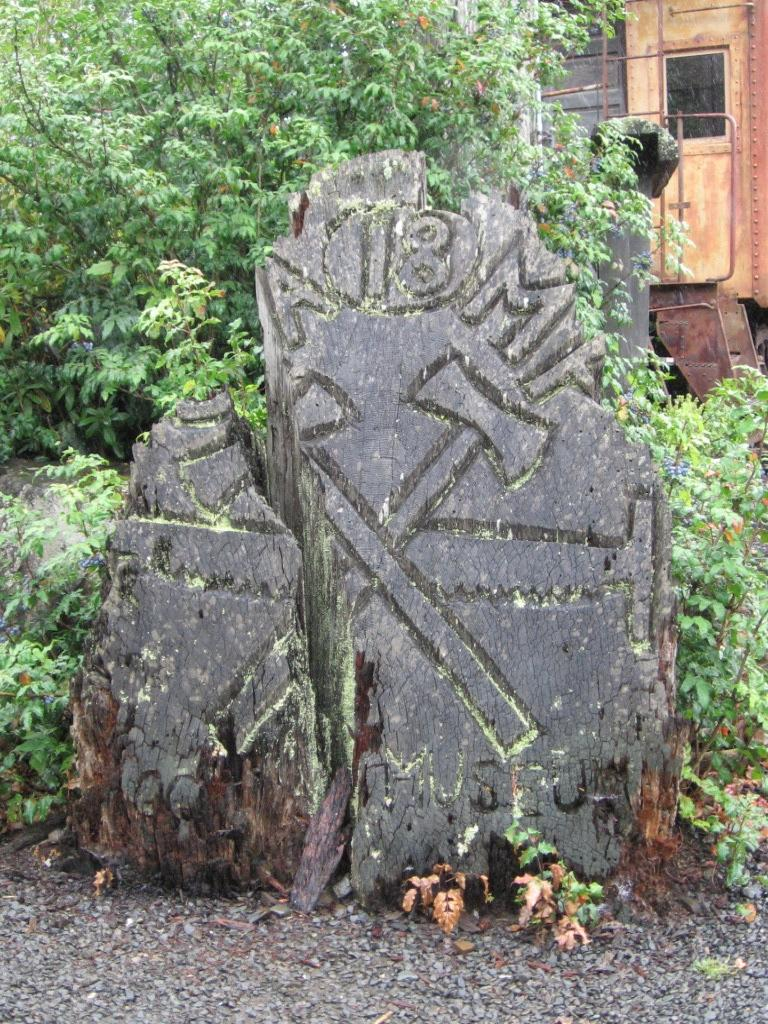What is the main subject of the image? The main subject of the image is a stone with carving. What type of terrain is visible at the bottom of the image? There is a rocky land at the bottom of the image. What can be seen in the background of the image? There are trees and other objects visible in the background of the image. How does the stone achieve a high grade in the image? The stone does not achieve a grade in the image; it is a carved stone on a rocky land with trees in the background. 